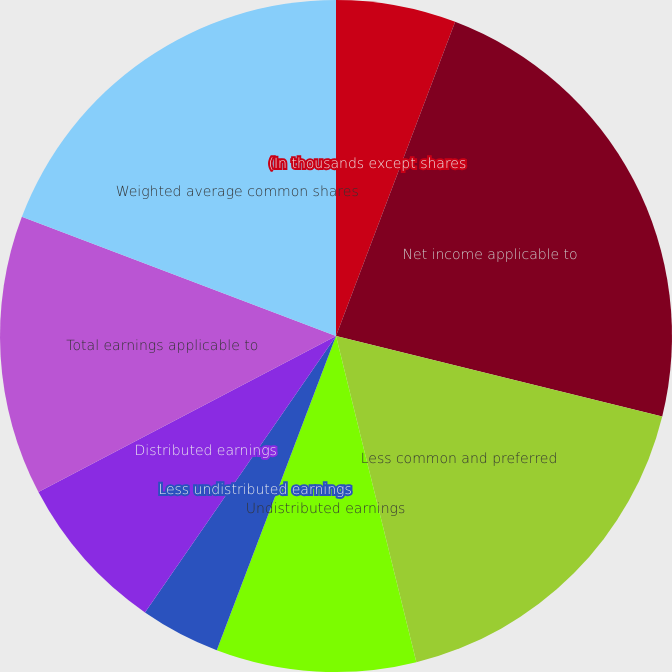<chart> <loc_0><loc_0><loc_500><loc_500><pie_chart><fcel>(In thousands except shares<fcel>Net income applicable to<fcel>Less common and preferred<fcel>Undistributed earnings<fcel>Less undistributed earnings<fcel>Distributed earnings<fcel>Total earnings applicable to<fcel>Weighted average common shares<fcel>Net earnings per common share<nl><fcel>5.77%<fcel>23.08%<fcel>17.31%<fcel>9.62%<fcel>3.85%<fcel>7.69%<fcel>13.46%<fcel>19.23%<fcel>0.0%<nl></chart> 